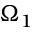Convert formula to latex. <formula><loc_0><loc_0><loc_500><loc_500>\Omega _ { 1 }</formula> 